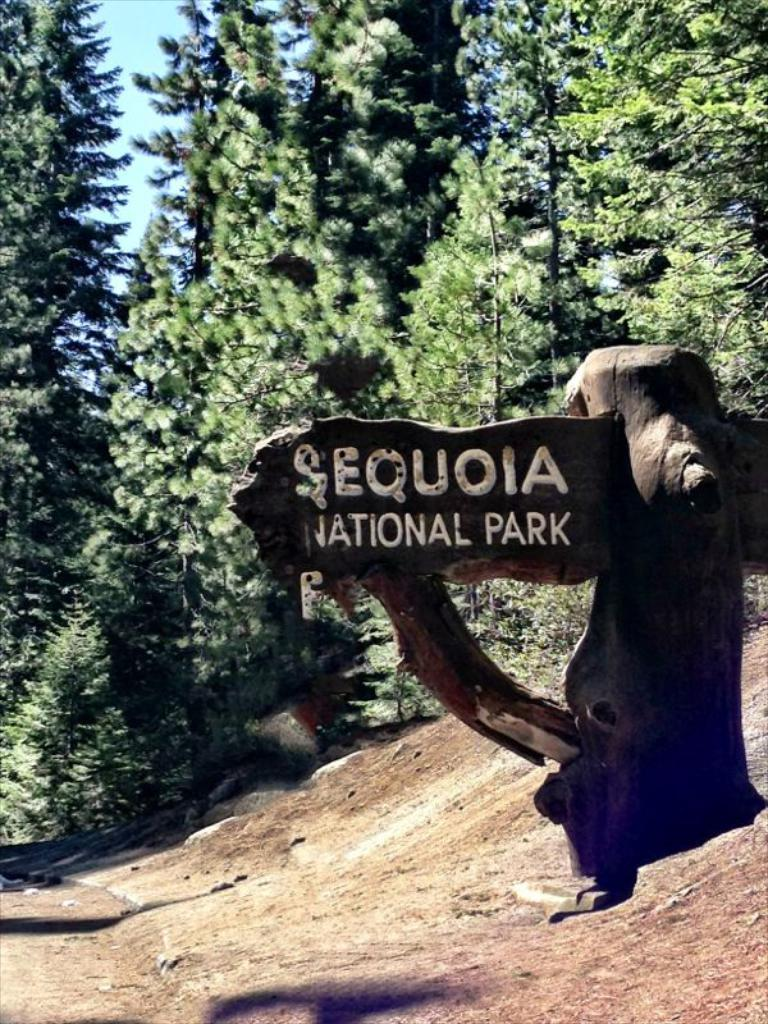What is the main object in the center of the image? There is a name board in the center of the image. What can be seen in the background of the image? There are trees in the background of the image. What is visible at the bottom of the image? There is a ground visible at the bottom of the image. What type of cake is being served on the name board in the image? There is no cake present in the image; it features a name board with no food items. 